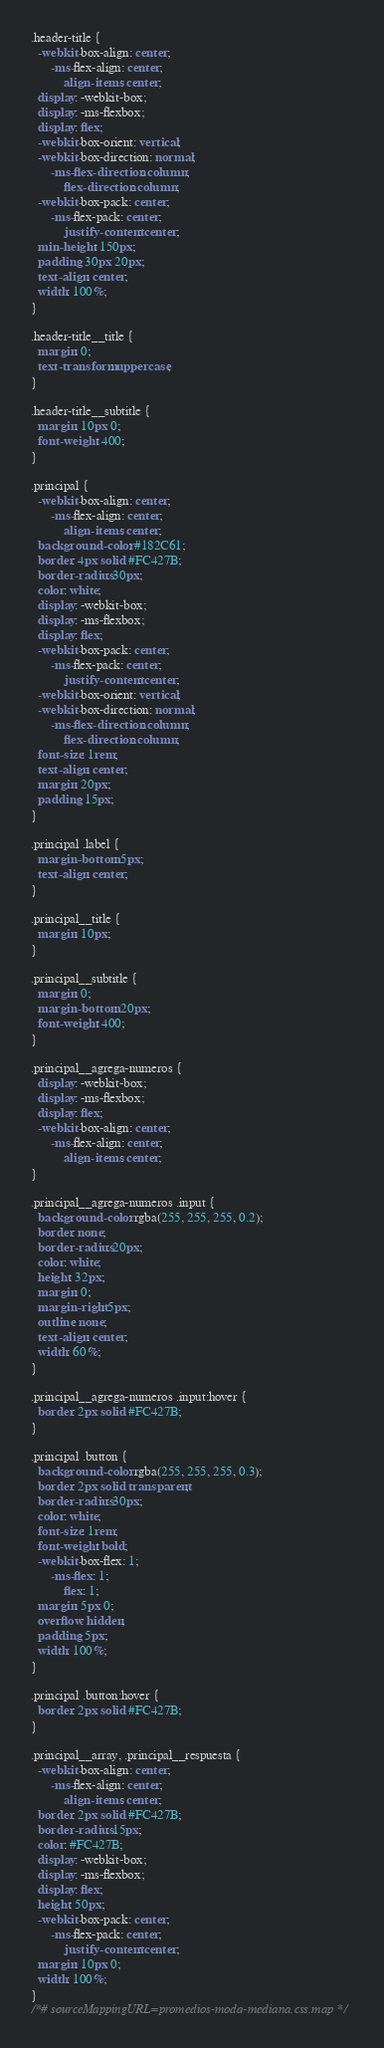Convert code to text. <code><loc_0><loc_0><loc_500><loc_500><_CSS_>.header-title {
  -webkit-box-align: center;
      -ms-flex-align: center;
          align-items: center;
  display: -webkit-box;
  display: -ms-flexbox;
  display: flex;
  -webkit-box-orient: vertical;
  -webkit-box-direction: normal;
      -ms-flex-direction: column;
          flex-direction: column;
  -webkit-box-pack: center;
      -ms-flex-pack: center;
          justify-content: center;
  min-height: 150px;
  padding: 30px 20px;
  text-align: center;
  width: 100%;
}

.header-title__title {
  margin: 0;
  text-transform: uppercase;
}

.header-title__subtitle {
  margin: 10px 0;
  font-weight: 400;
}

.principal {
  -webkit-box-align: center;
      -ms-flex-align: center;
          align-items: center;
  background-color: #182C61;
  border: 4px solid #FC427B;
  border-radius: 30px;
  color: white;
  display: -webkit-box;
  display: -ms-flexbox;
  display: flex;
  -webkit-box-pack: center;
      -ms-flex-pack: center;
          justify-content: center;
  -webkit-box-orient: vertical;
  -webkit-box-direction: normal;
      -ms-flex-direction: column;
          flex-direction: column;
  font-size: 1rem;
  text-align: center;
  margin: 20px;
  padding: 15px;
}

.principal .label {
  margin-bottom: 5px;
  text-align: center;
}

.principal__title {
  margin: 10px;
}

.principal__subtitle {
  margin: 0;
  margin-bottom: 20px;
  font-weight: 400;
}

.principal__agrega-numeros {
  display: -webkit-box;
  display: -ms-flexbox;
  display: flex;
  -webkit-box-align: center;
      -ms-flex-align: center;
          align-items: center;
}

.principal__agrega-numeros .input {
  background-color: rgba(255, 255, 255, 0.2);
  border: none;
  border-radius: 20px;
  color: white;
  height: 32px;
  margin: 0;
  margin-right: 5px;
  outline: none;
  text-align: center;
  width: 60%;
}

.principal__agrega-numeros .input:hover {
  border: 2px solid #FC427B;
}

.principal .button {
  background-color: rgba(255, 255, 255, 0.3);
  border: 2px solid transparent;
  border-radius: 30px;
  color: white;
  font-size: 1rem;
  font-weight: bold;
  -webkit-box-flex: 1;
      -ms-flex: 1;
          flex: 1;
  margin: 5px 0;
  overflow: hidden;
  padding: 5px;
  width: 100%;
}

.principal .button:hover {
  border: 2px solid #FC427B;
}

.principal__array, .principal__respuesta {
  -webkit-box-align: center;
      -ms-flex-align: center;
          align-items: center;
  border: 2px solid #FC427B;
  border-radius: 15px;
  color: #FC427B;
  display: -webkit-box;
  display: -ms-flexbox;
  display: flex;
  height: 50px;
  -webkit-box-pack: center;
      -ms-flex-pack: center;
          justify-content: center;
  margin: 10px 0;
  width: 100%;
}
/*# sourceMappingURL=promedios-moda-mediana.css.map */</code> 